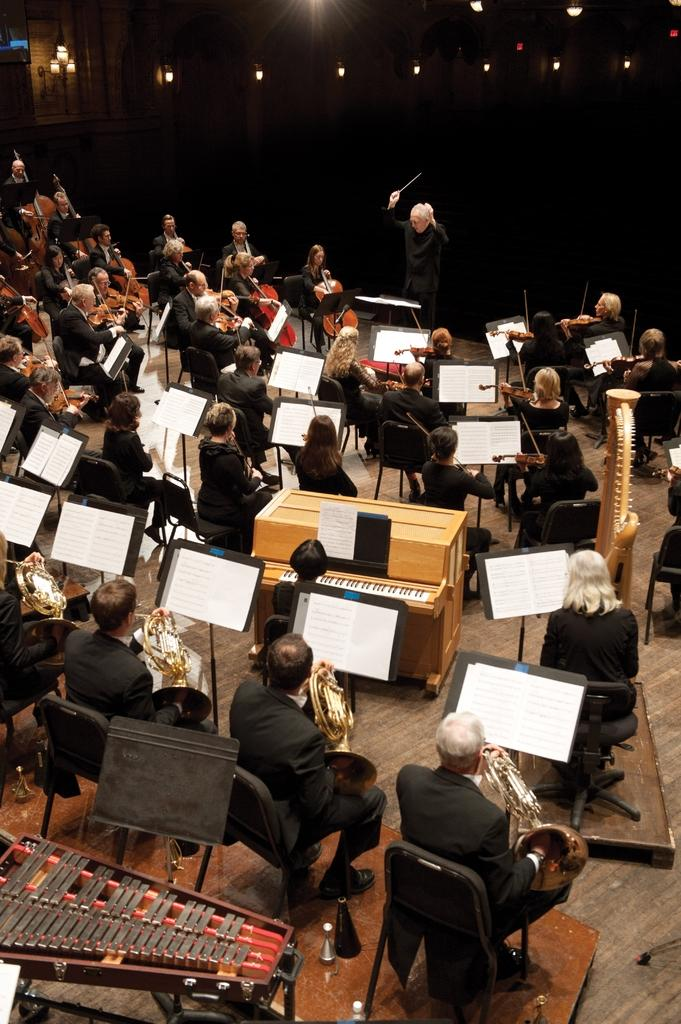What are the persons in the image doing? The persons in the image are playing guitar. What objects can be seen near the persons? There are chairs and books visible in the image. What can be seen in the background of the image? There are lights visible in the background of the image. What is visible beneath the persons and objects in the image? The floor is visible in the image. What type of crayon is being used to draw on the floor in the image? There is no crayon or drawing on the floor present in the image; the persons are playing guitar and the floor is visible but not being used for drawing. 